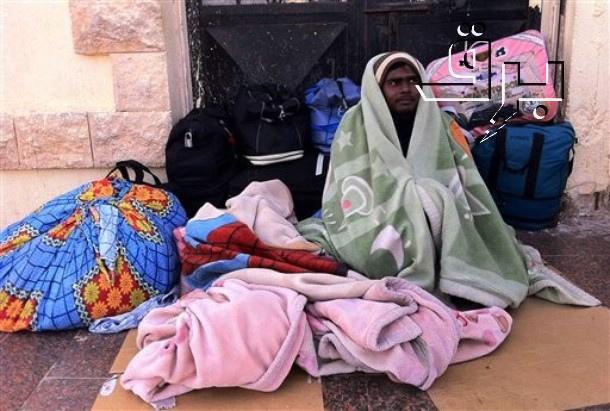What color is the blanket on the ground?
Quick response, please. Pink. Is this person outside?
Be succinct. Yes. Is there a person in this picture?
Write a very short answer. Yes. 